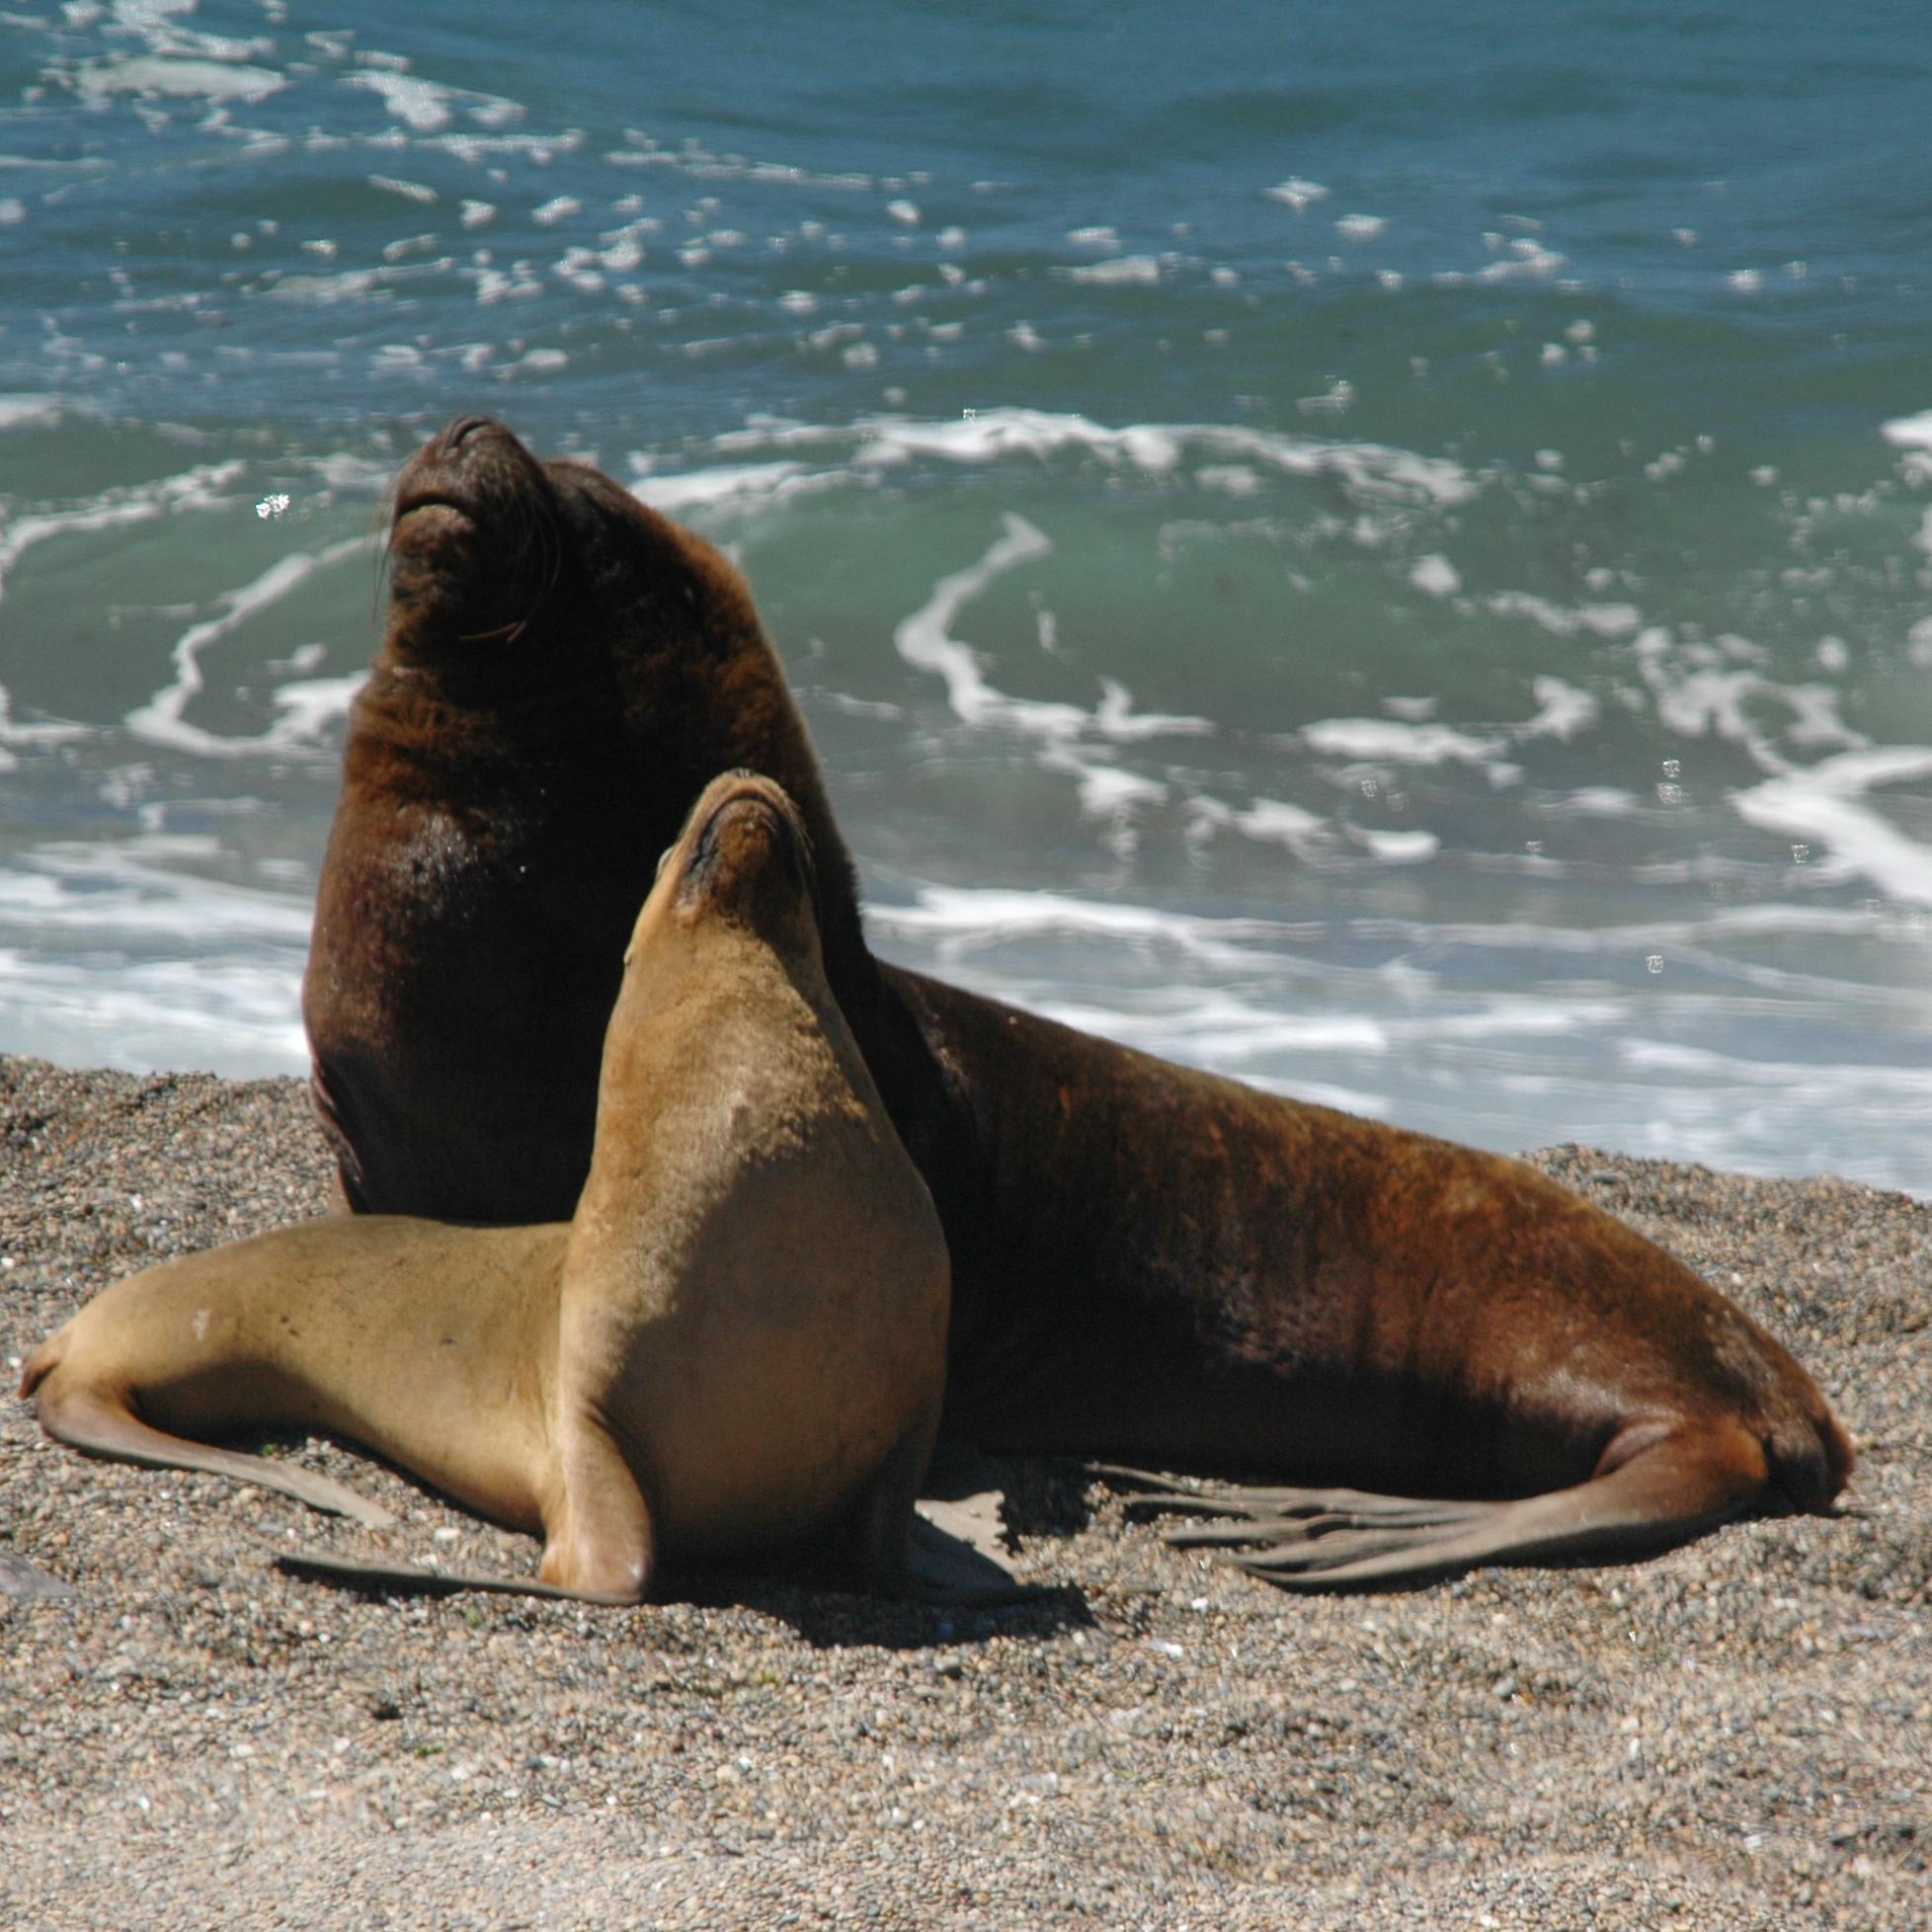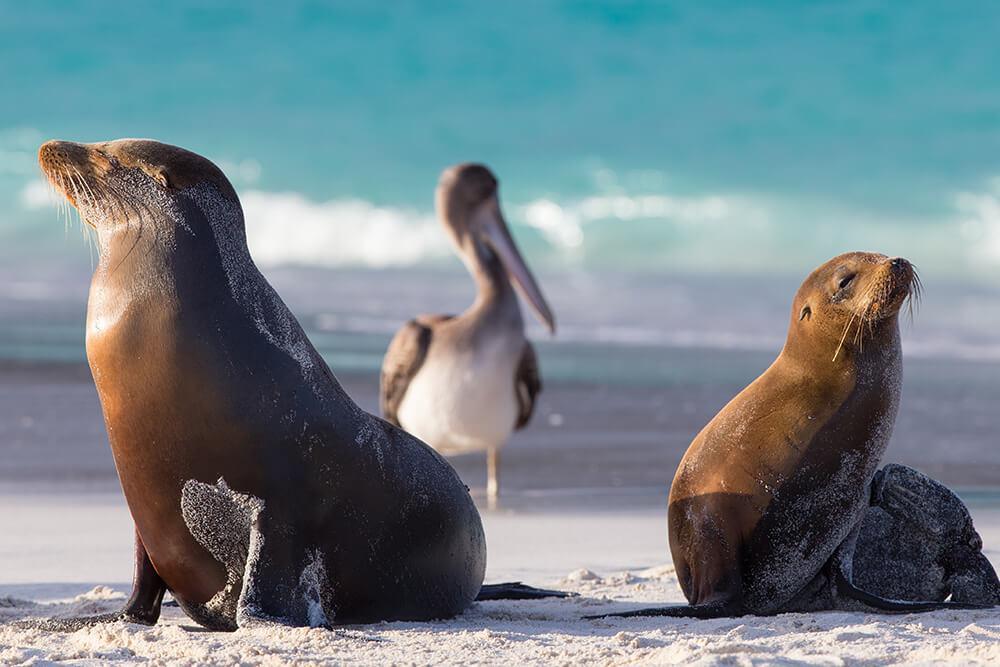The first image is the image on the left, the second image is the image on the right. Analyze the images presented: Is the assertion "There is more than one seal in at least one image." valid? Answer yes or no. Yes. 